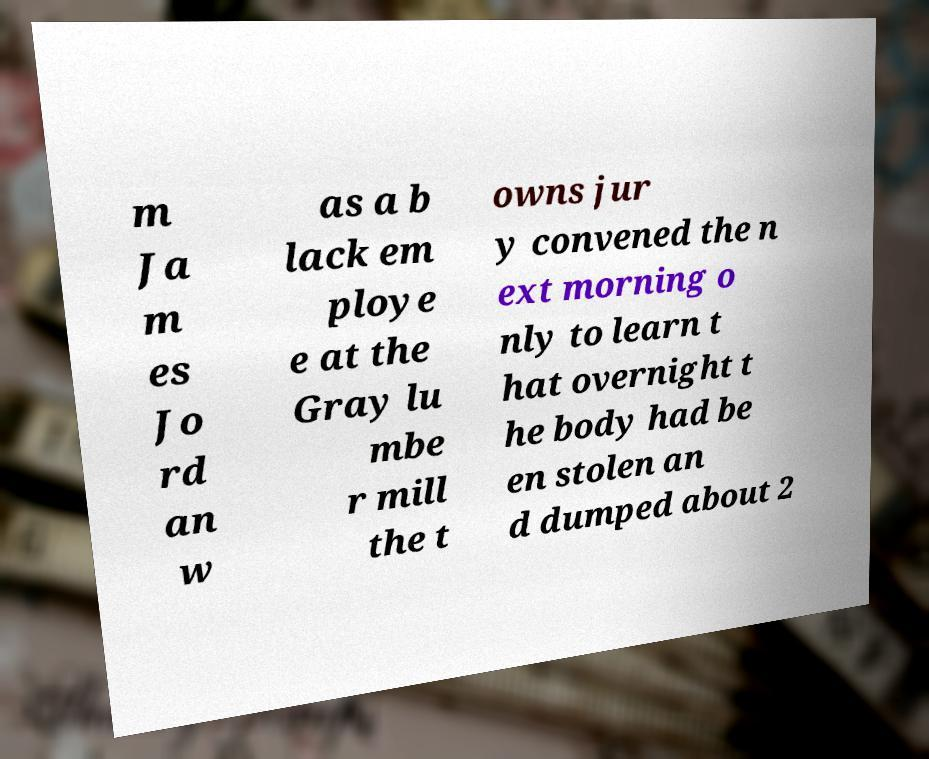There's text embedded in this image that I need extracted. Can you transcribe it verbatim? m Ja m es Jo rd an w as a b lack em ploye e at the Gray lu mbe r mill the t owns jur y convened the n ext morning o nly to learn t hat overnight t he body had be en stolen an d dumped about 2 